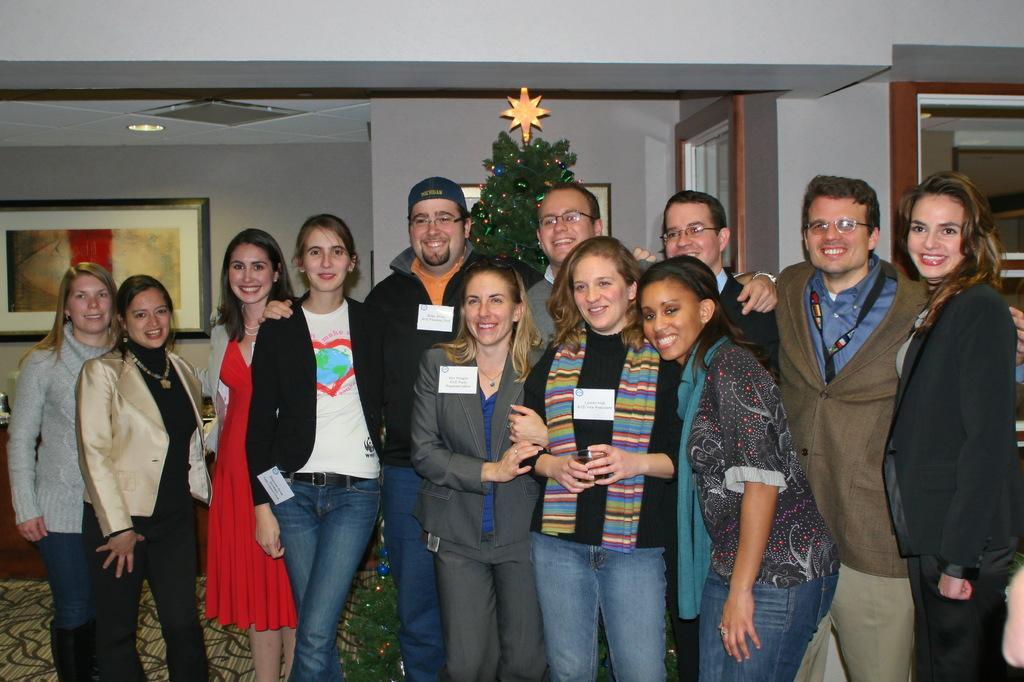Can you describe this image briefly? In this image we can see these women and men are standing on the floor and smiling. In the background, we can see the Xmas tree, glass windows and photo frames on the wall. Here we can see the ceiling lights. 